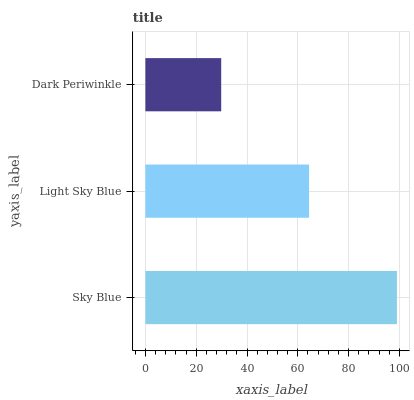Is Dark Periwinkle the minimum?
Answer yes or no. Yes. Is Sky Blue the maximum?
Answer yes or no. Yes. Is Light Sky Blue the minimum?
Answer yes or no. No. Is Light Sky Blue the maximum?
Answer yes or no. No. Is Sky Blue greater than Light Sky Blue?
Answer yes or no. Yes. Is Light Sky Blue less than Sky Blue?
Answer yes or no. Yes. Is Light Sky Blue greater than Sky Blue?
Answer yes or no. No. Is Sky Blue less than Light Sky Blue?
Answer yes or no. No. Is Light Sky Blue the high median?
Answer yes or no. Yes. Is Light Sky Blue the low median?
Answer yes or no. Yes. Is Dark Periwinkle the high median?
Answer yes or no. No. Is Dark Periwinkle the low median?
Answer yes or no. No. 